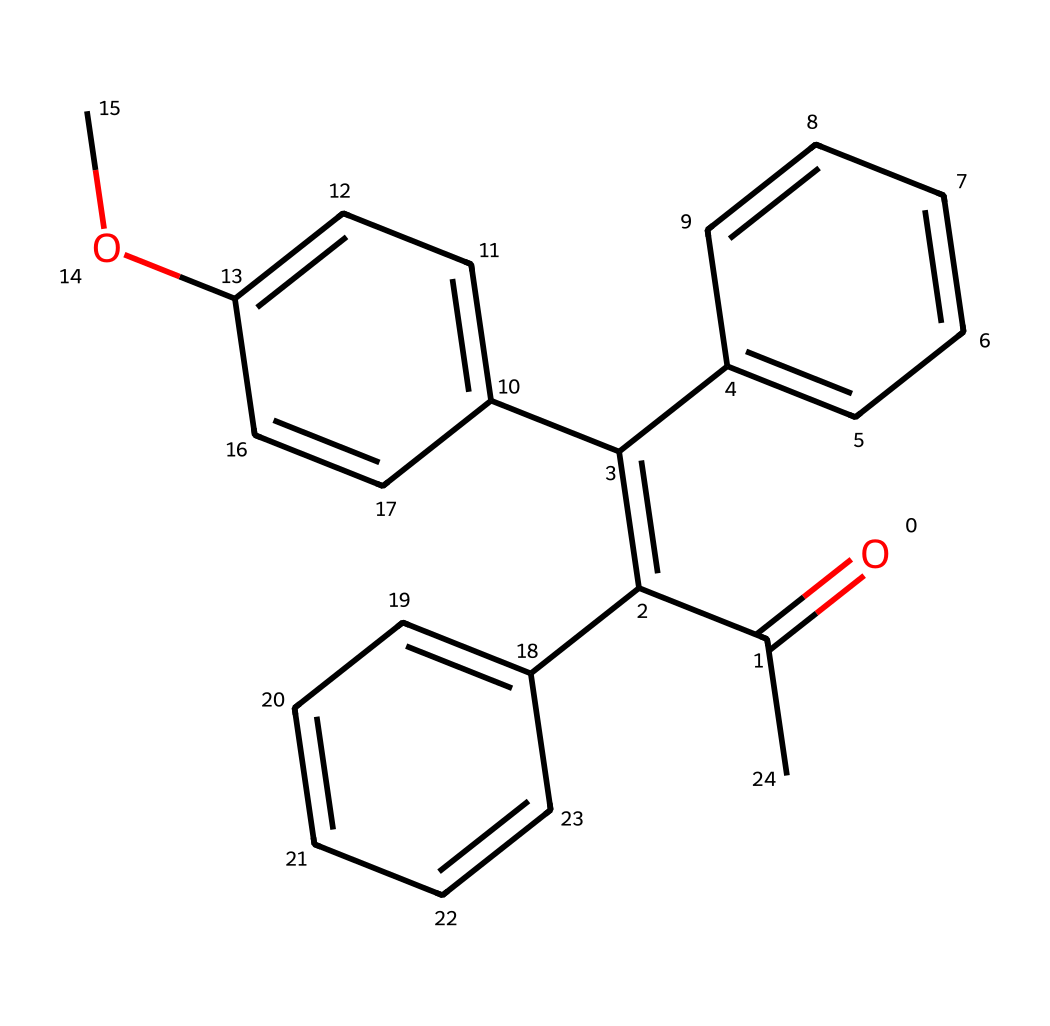What is the main functional group present in this chemical? The structure contains a carbonyl group (C=O) which indicates the presence of ketones or aldehydes, specifically in the structure as a result of the O=C portion in the SMILES.
Answer: carbonyl How many rings are present in this chemical structure? By analyzing the structure, we observe three distinct ring structures formed by the cyclical carbon arrangements,  indicated by the series of numbers in the SMILES representation.
Answer: three What type of reaction is this chemical primarily used for in sunscreens? The presence of the carbonyl group and conjugated double bonds implies that this chemical is a photoreactive compound, commonly used for absorbing UV radiation in sunscreens leading to photochemical reactions.
Answer: UV absorption What is the molecular complexity of this compound, low or high? The structure consists of multiple interconnected carbon rings and a carbonyl group, suggesting that it is complex. Complexity typically denotes numerous connections and rings, so this compound can be classified as high complexity.
Answer: high How many different types of functional groups are identifiable in this molecule? In examining the structure, we see a carbonyl functional group and an ether functional group (-O-) in the methoxy group, indicating at least two distinct types of functional groups within the entire compound.
Answer: two 